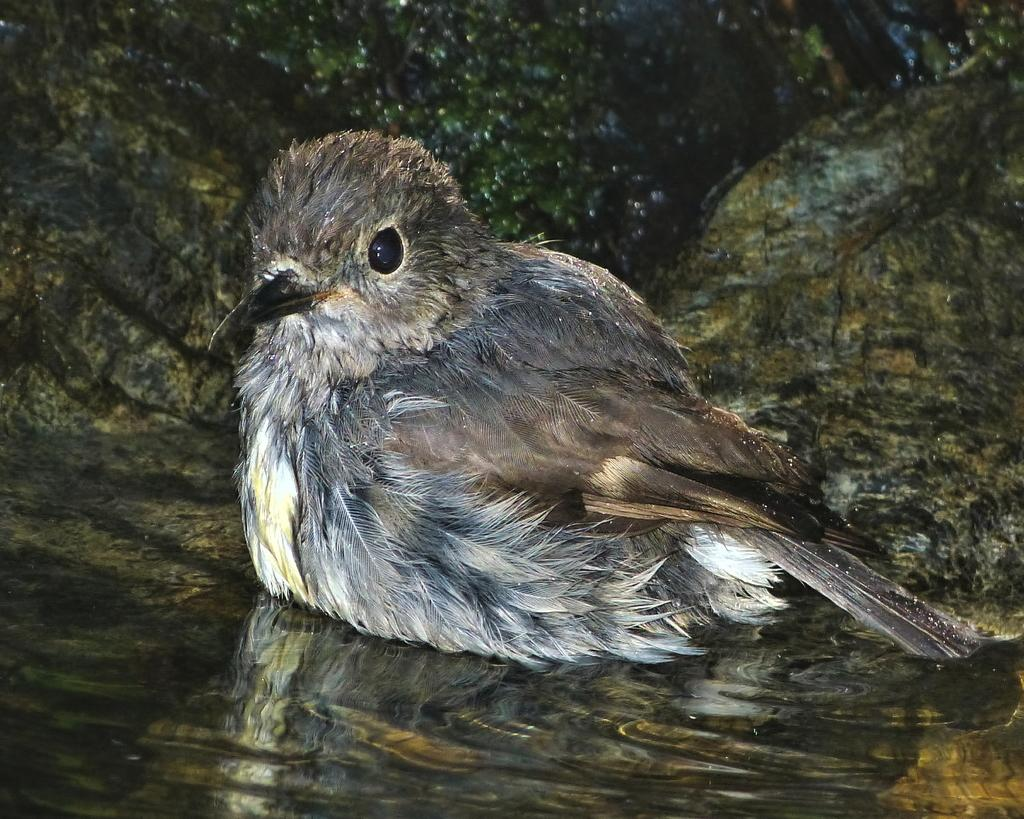What type of animal is in the image? There is a bird in the image. Can you describe the bird's appearance? The bird is gray and light brown in color. Where is the bird located in the image? The bird is on the water. What else can be seen in the image besides the bird? There are stones visible in the image. What type of gun is the woman holding in the image? There is no woman or gun present in the image; it features a bird on the water and stones. 